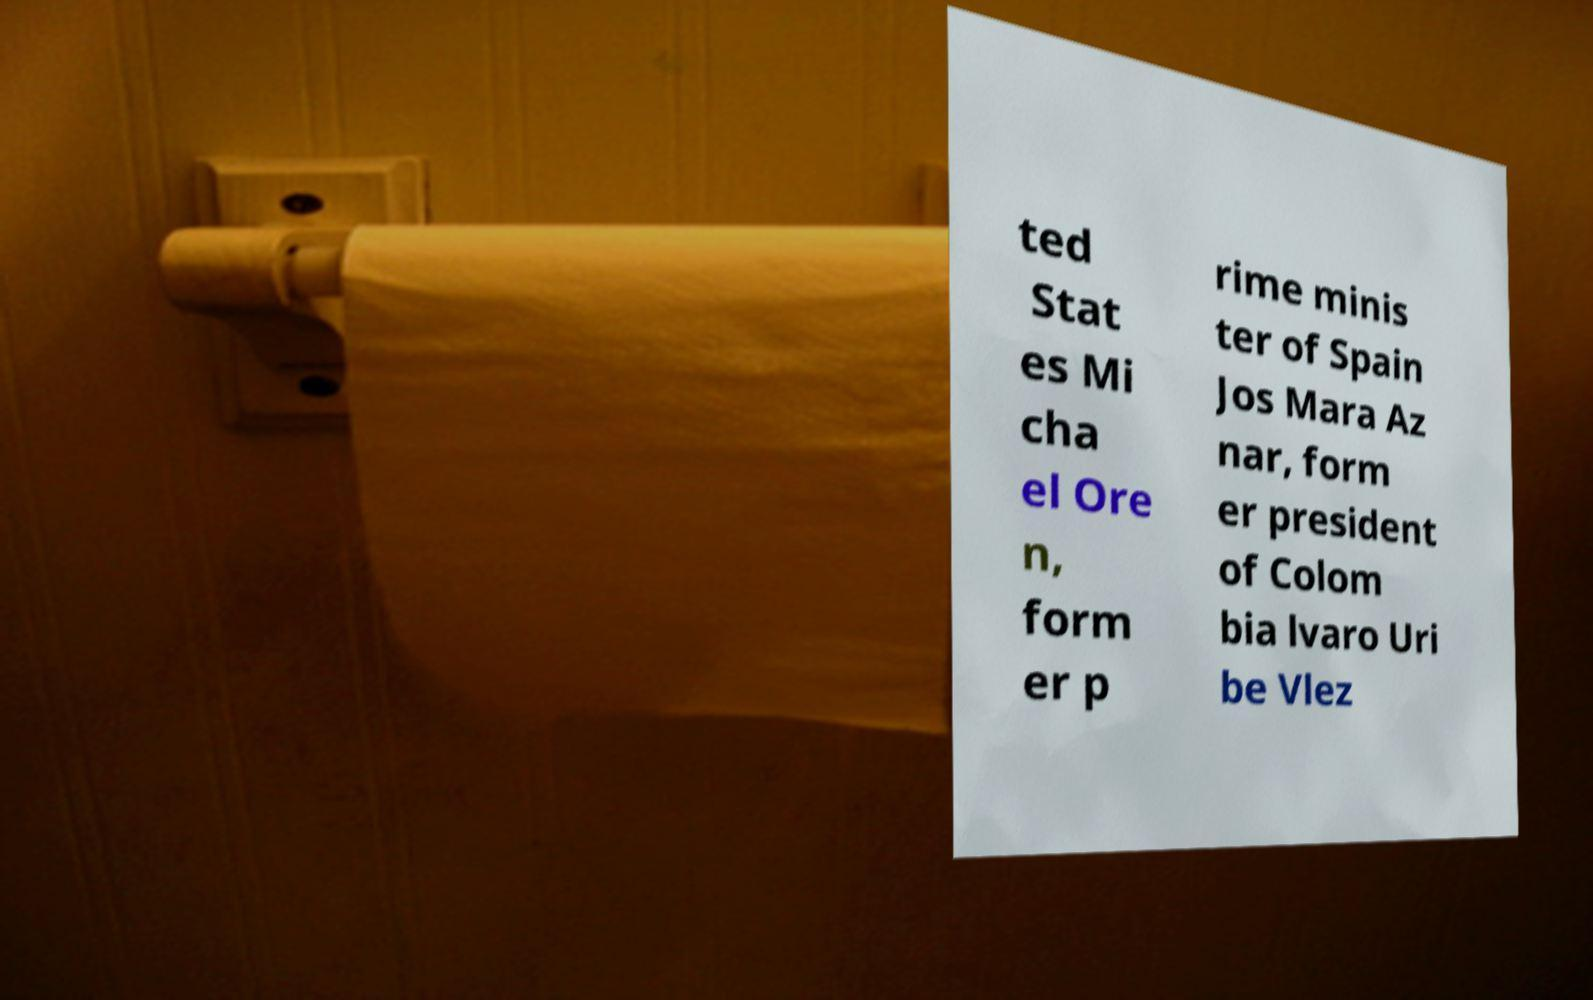Could you extract and type out the text from this image? ted Stat es Mi cha el Ore n, form er p rime minis ter of Spain Jos Mara Az nar, form er president of Colom bia lvaro Uri be Vlez 